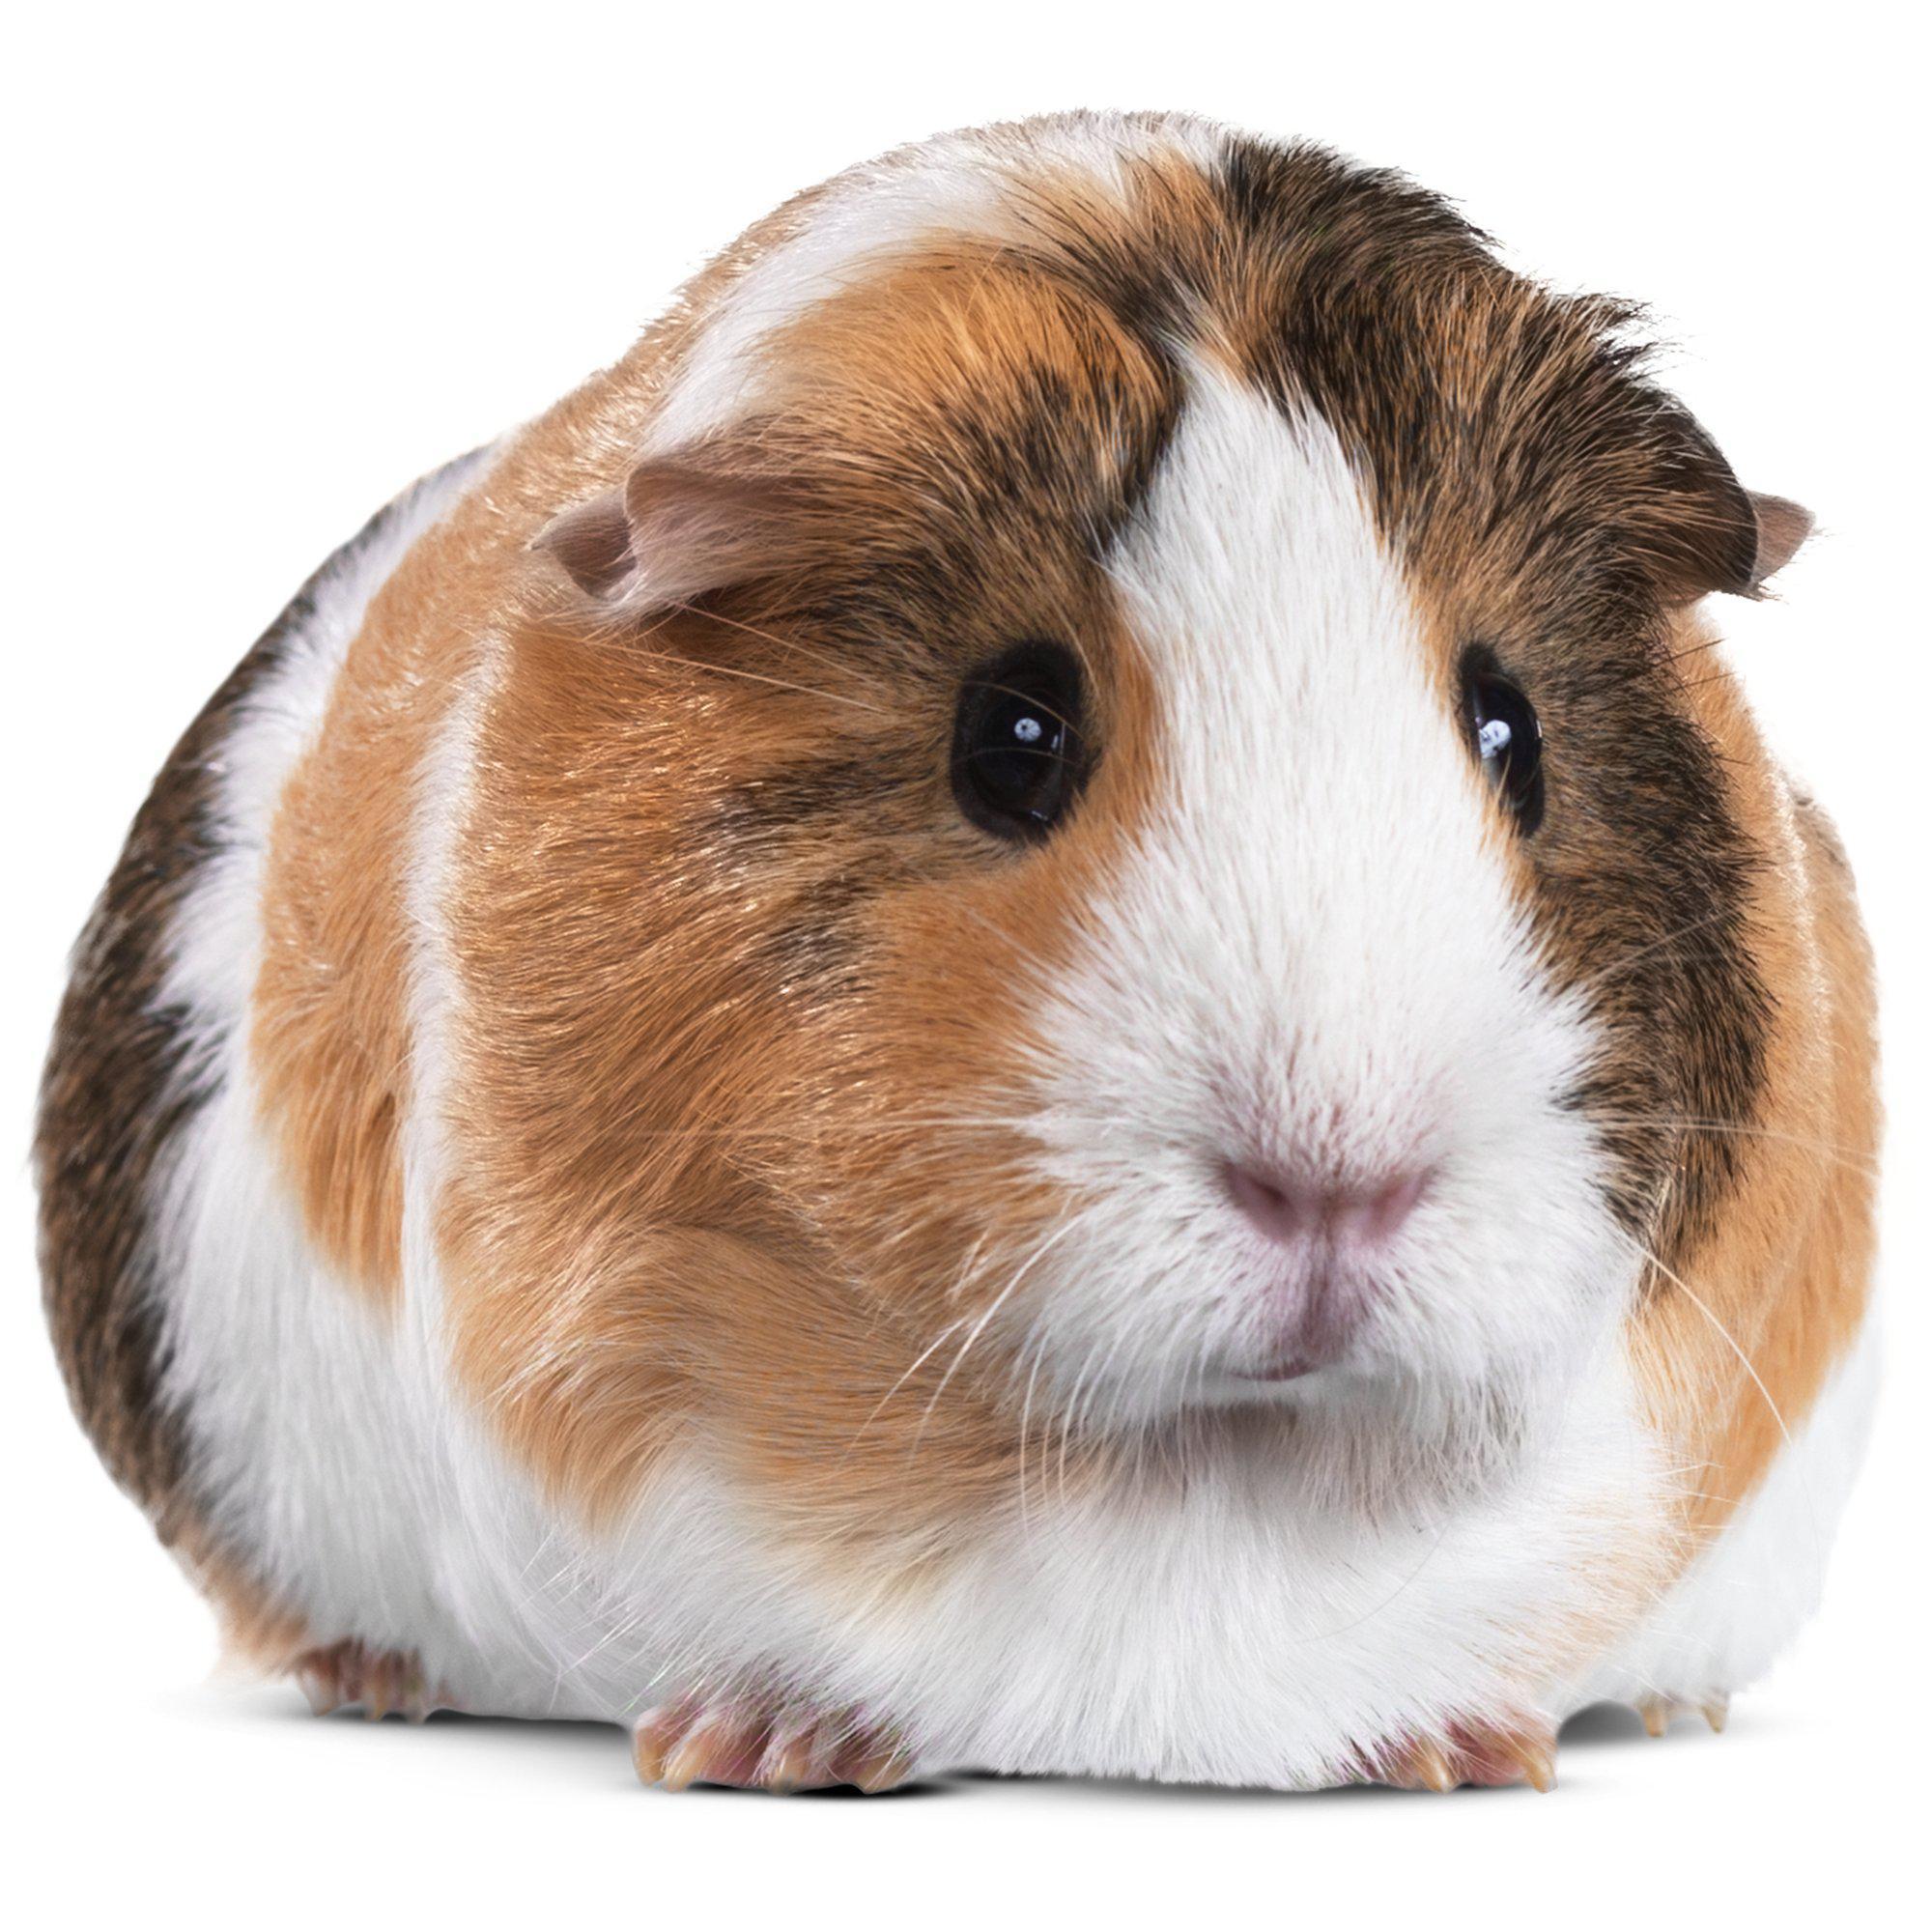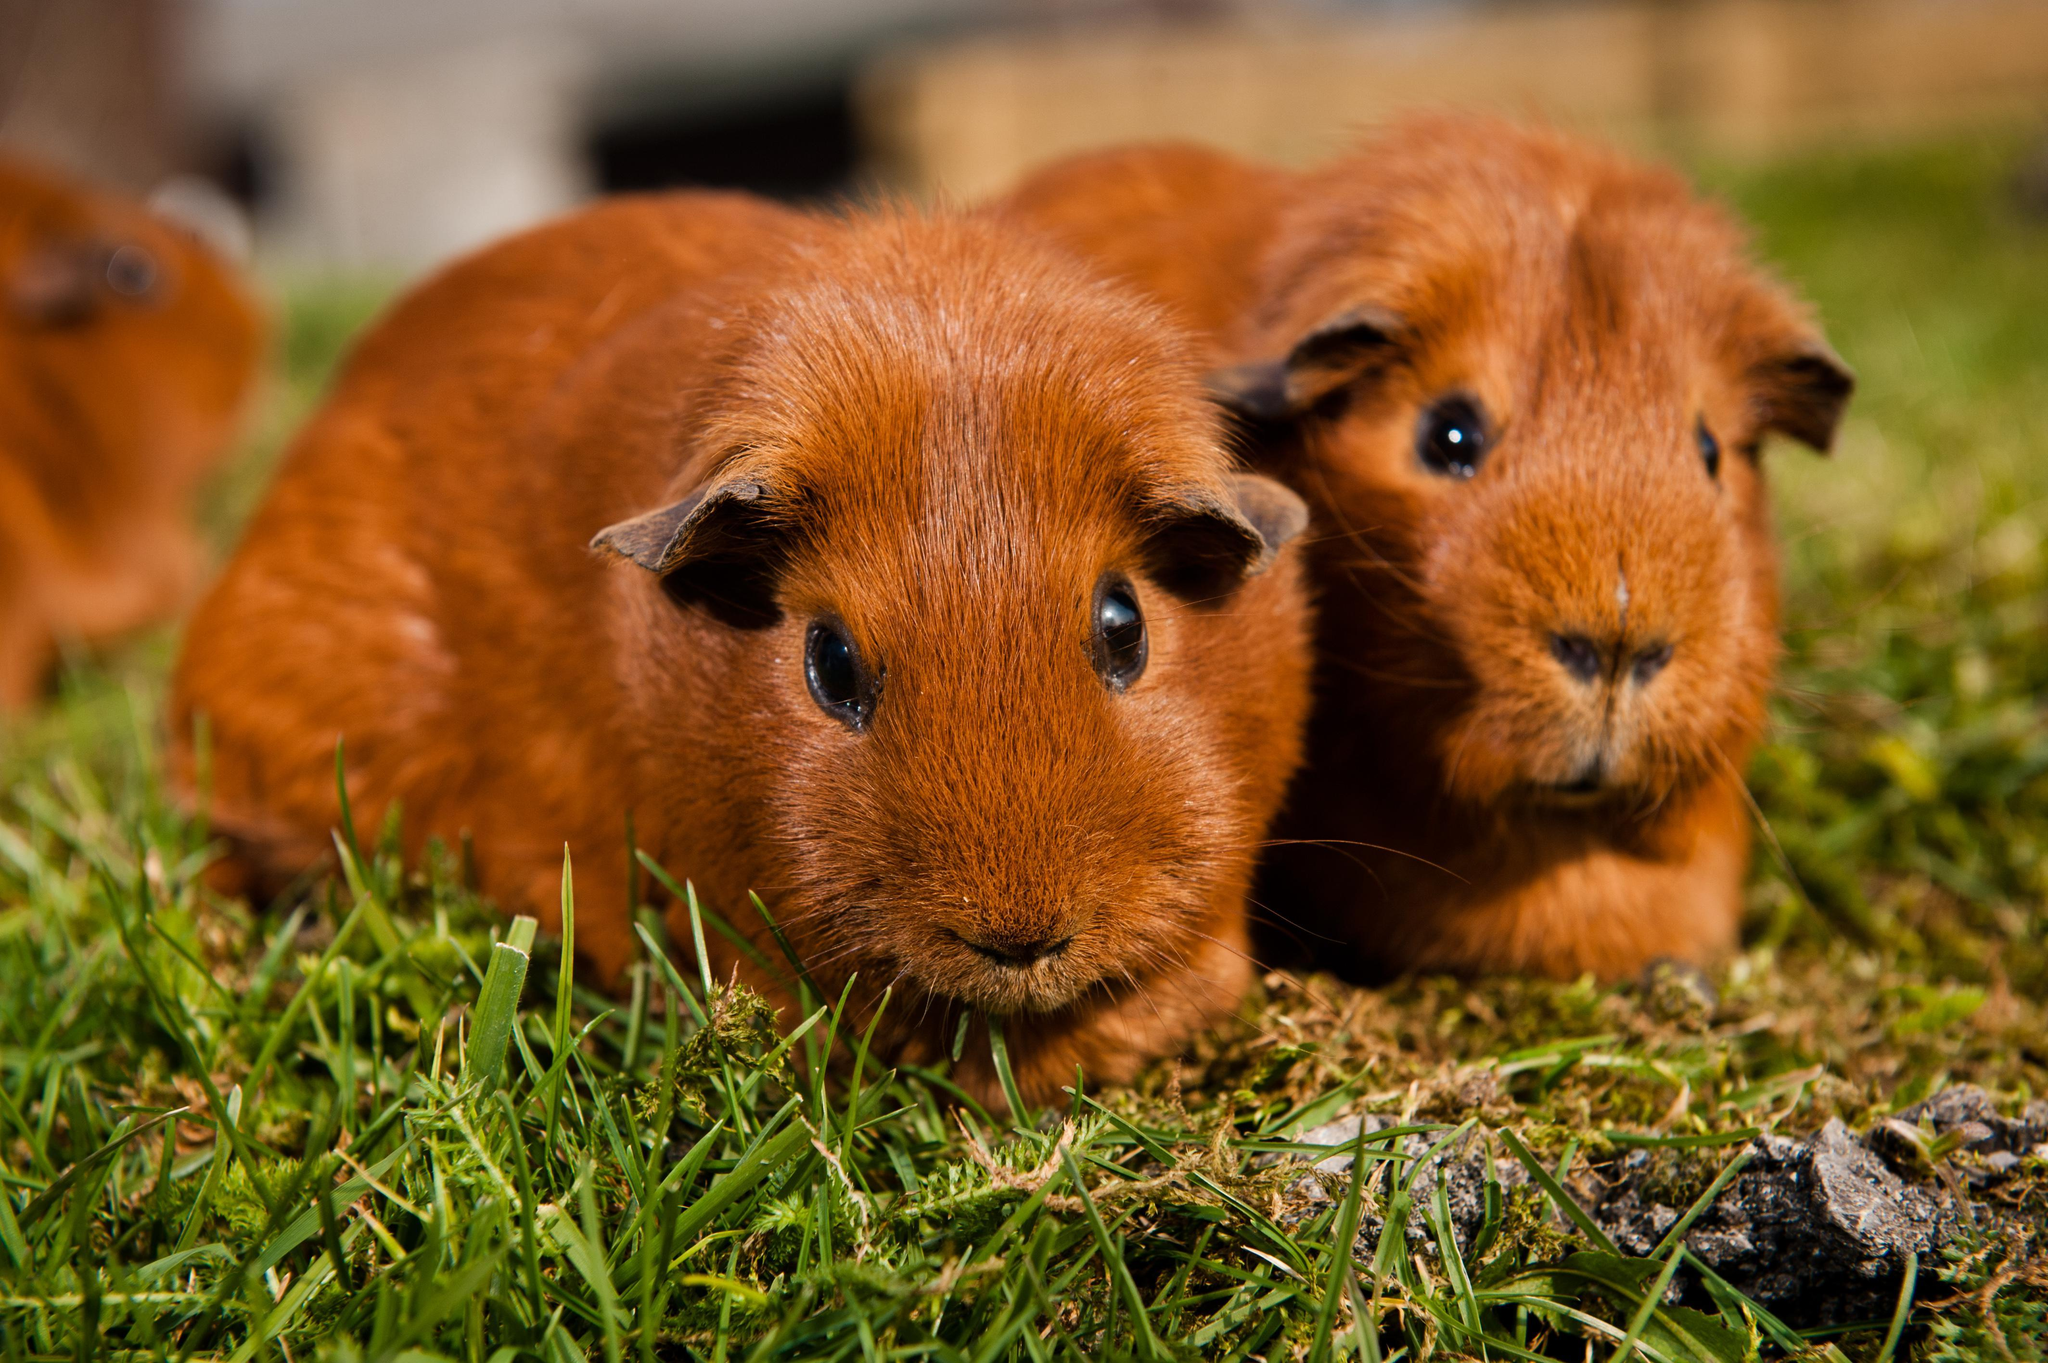The first image is the image on the left, the second image is the image on the right. For the images displayed, is the sentence "There are three guinea pigs" factually correct? Answer yes or no. Yes. 